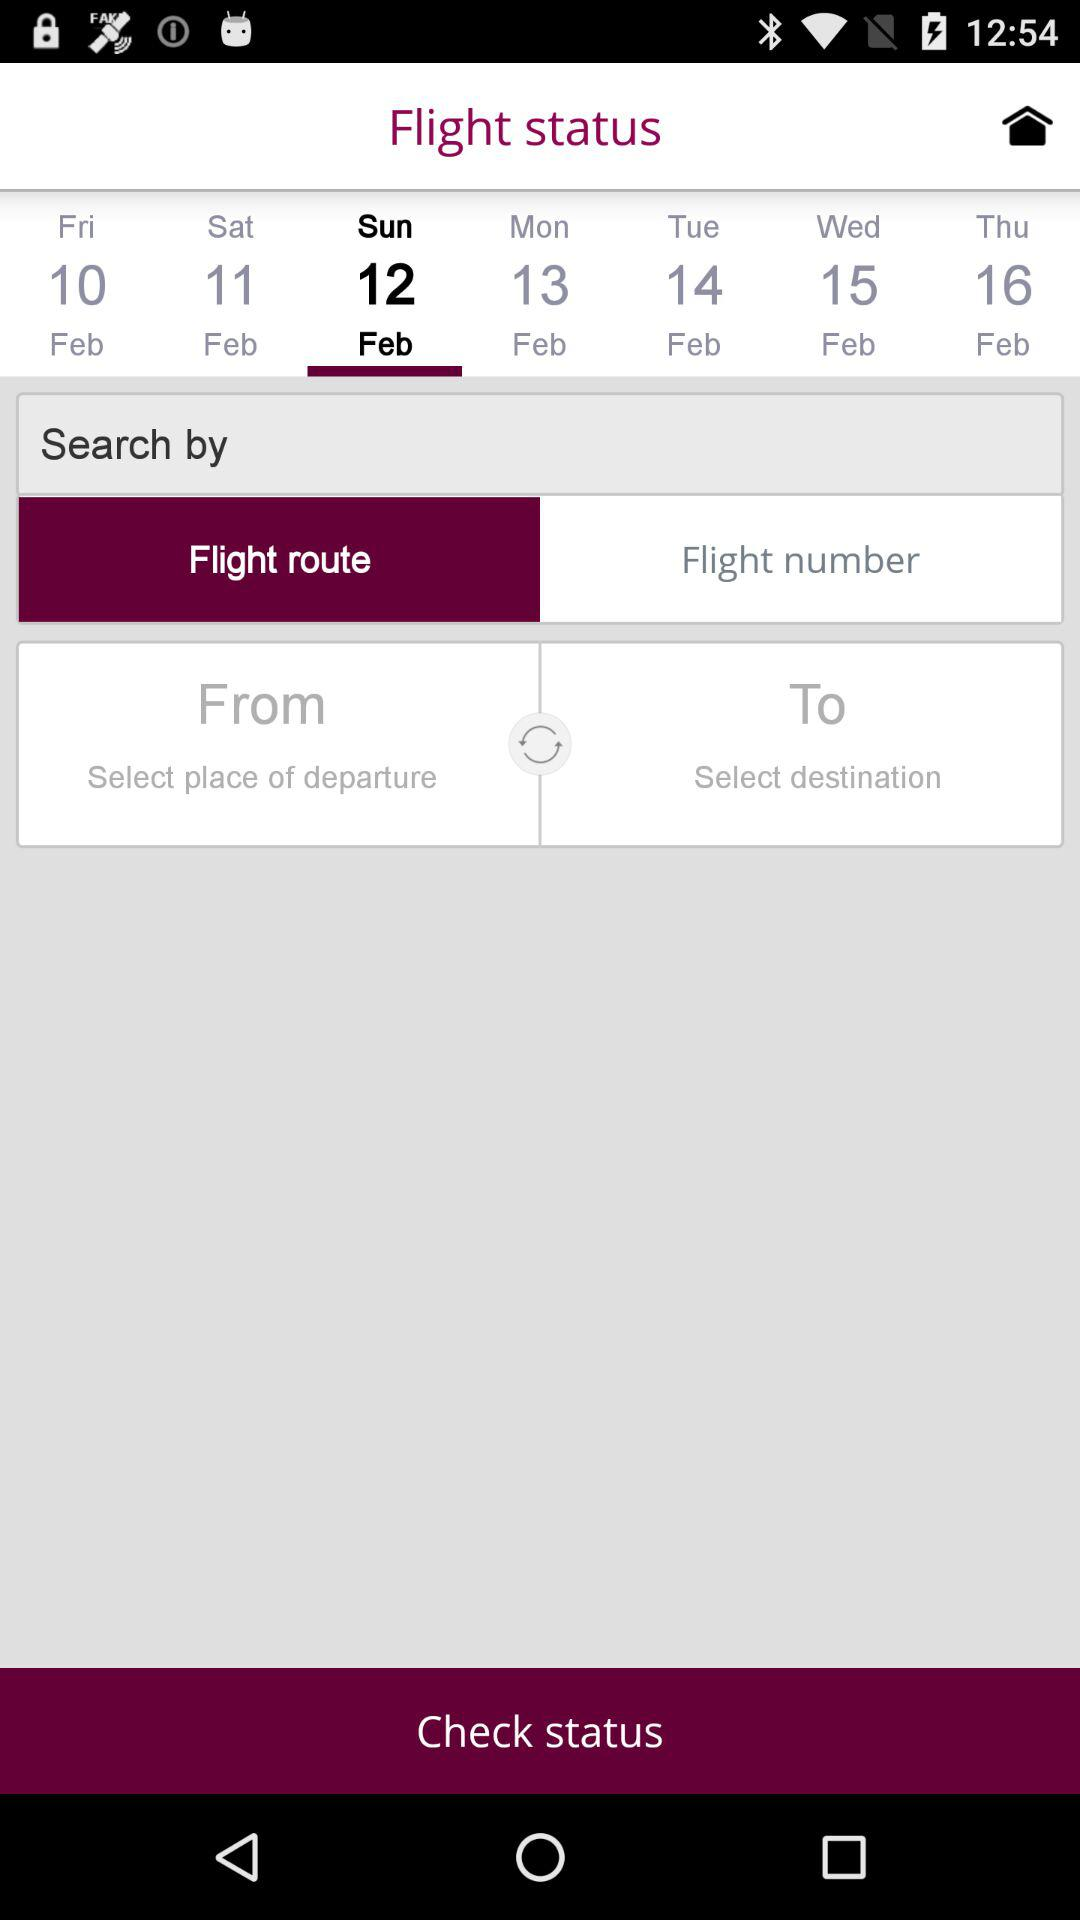Which date is selected? The selected date is Sunday, February 12. 